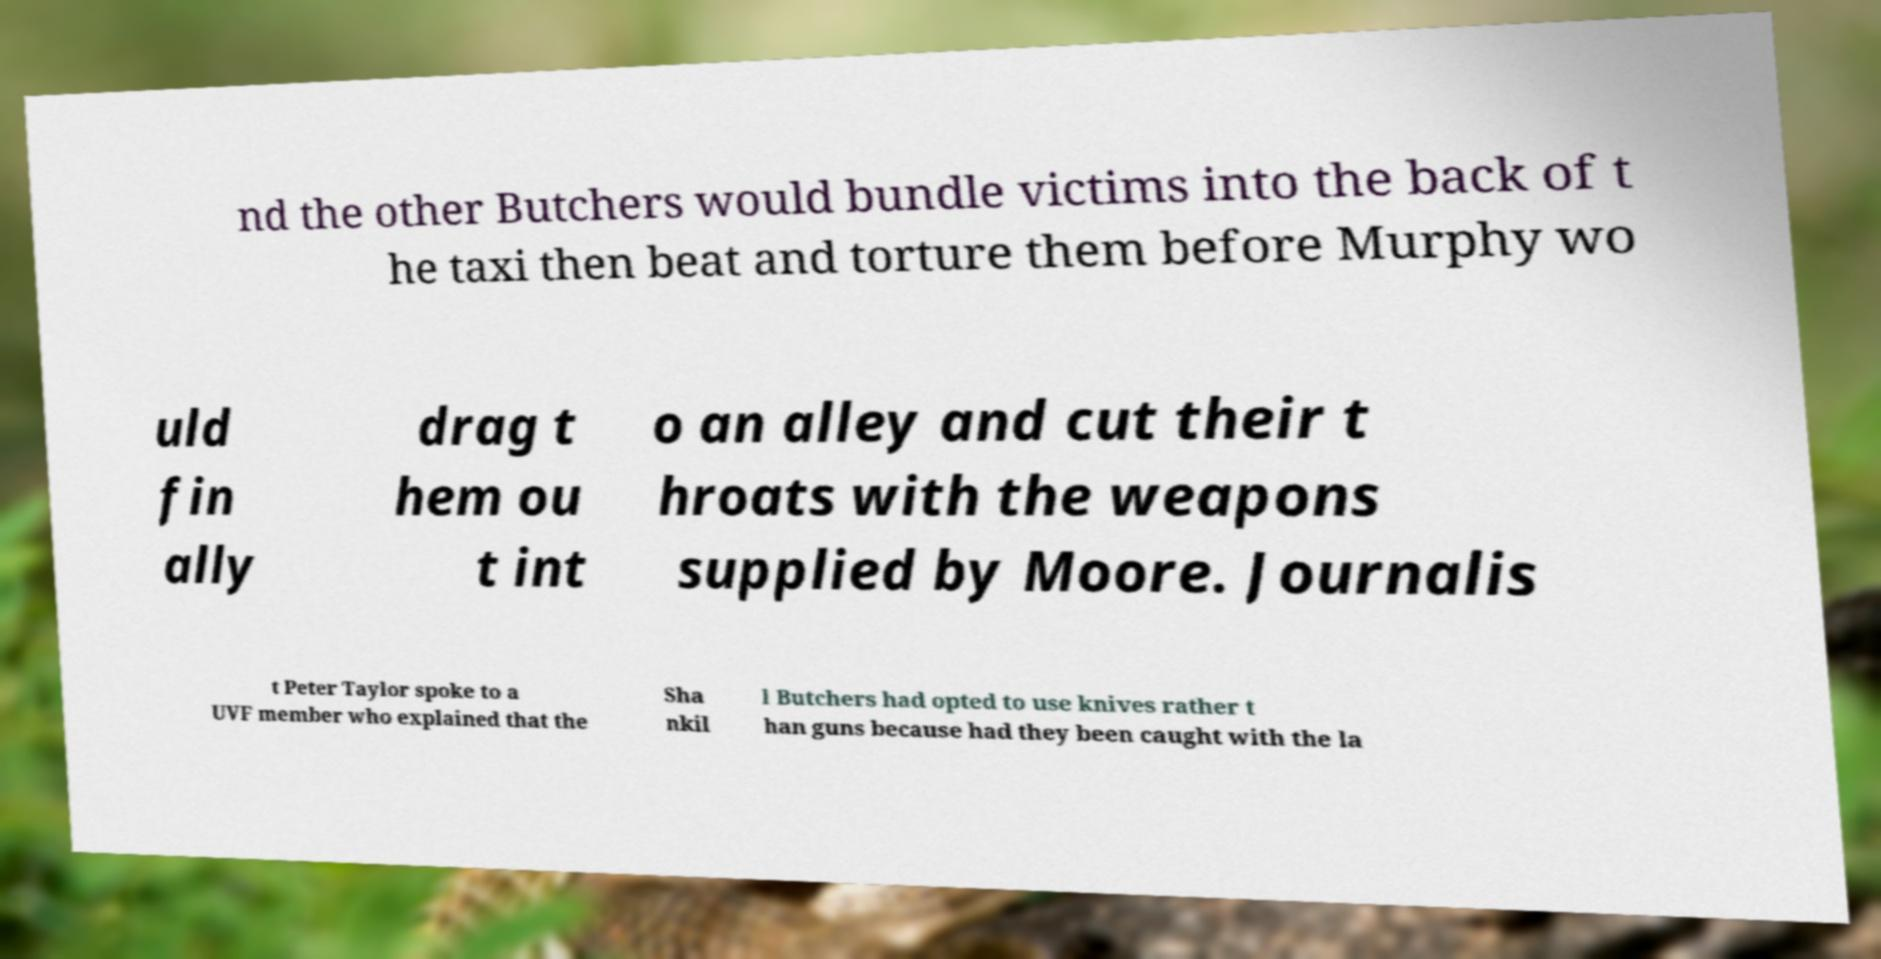Please identify and transcribe the text found in this image. nd the other Butchers would bundle victims into the back of t he taxi then beat and torture them before Murphy wo uld fin ally drag t hem ou t int o an alley and cut their t hroats with the weapons supplied by Moore. Journalis t Peter Taylor spoke to a UVF member who explained that the Sha nkil l Butchers had opted to use knives rather t han guns because had they been caught with the la 